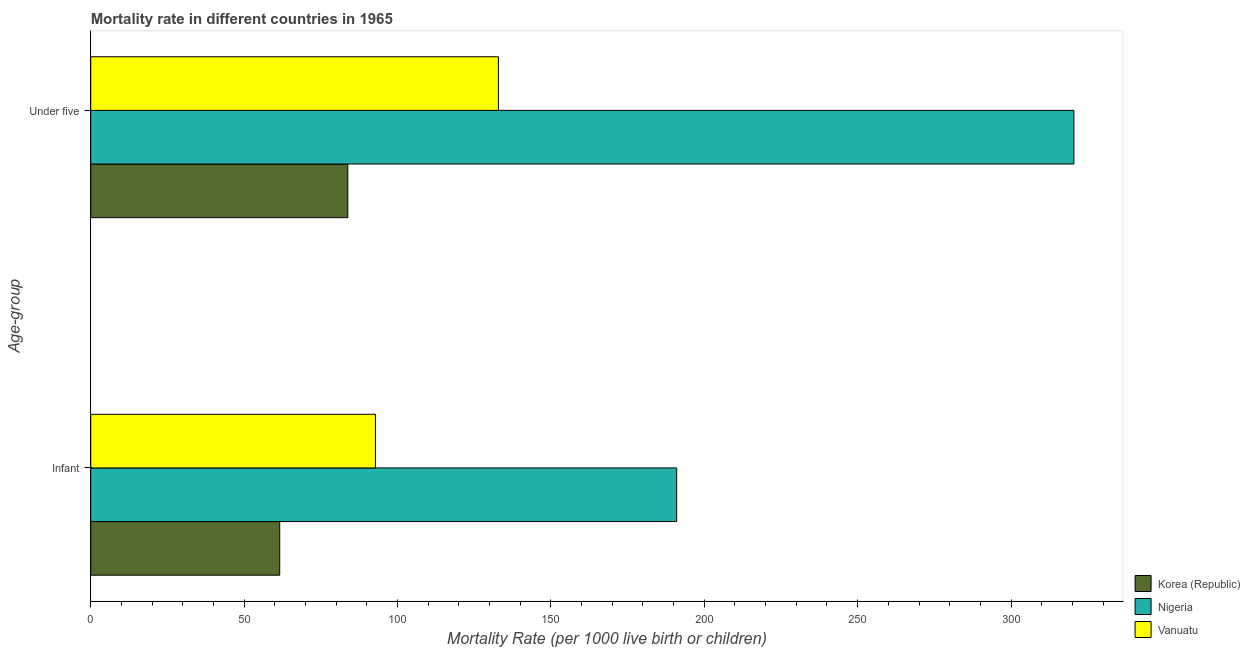How many groups of bars are there?
Your response must be concise. 2. Are the number of bars on each tick of the Y-axis equal?
Your answer should be compact. Yes. How many bars are there on the 1st tick from the top?
Provide a succinct answer. 3. How many bars are there on the 1st tick from the bottom?
Your response must be concise. 3. What is the label of the 1st group of bars from the top?
Your response must be concise. Under five. What is the infant mortality rate in Vanuatu?
Make the answer very short. 92.8. Across all countries, what is the maximum infant mortality rate?
Your answer should be compact. 191. Across all countries, what is the minimum under-5 mortality rate?
Your answer should be compact. 83.8. In which country was the infant mortality rate maximum?
Give a very brief answer. Nigeria. In which country was the infant mortality rate minimum?
Make the answer very short. Korea (Republic). What is the total infant mortality rate in the graph?
Your answer should be very brief. 345.4. What is the difference between the under-5 mortality rate in Nigeria and that in Korea (Republic)?
Provide a succinct answer. 236.7. What is the difference between the under-5 mortality rate in Nigeria and the infant mortality rate in Korea (Republic)?
Your answer should be very brief. 258.9. What is the average under-5 mortality rate per country?
Keep it short and to the point. 179.07. What is the difference between the under-5 mortality rate and infant mortality rate in Korea (Republic)?
Keep it short and to the point. 22.2. In how many countries, is the infant mortality rate greater than 60 ?
Offer a very short reply. 3. What is the ratio of the infant mortality rate in Vanuatu to that in Nigeria?
Give a very brief answer. 0.49. Is the under-5 mortality rate in Korea (Republic) less than that in Vanuatu?
Provide a short and direct response. Yes. In how many countries, is the infant mortality rate greater than the average infant mortality rate taken over all countries?
Keep it short and to the point. 1. What does the 2nd bar from the top in Under five represents?
Give a very brief answer. Nigeria. What does the 3rd bar from the bottom in Infant represents?
Give a very brief answer. Vanuatu. How many bars are there?
Your answer should be compact. 6. Are all the bars in the graph horizontal?
Offer a very short reply. Yes. How many countries are there in the graph?
Your answer should be compact. 3. What is the difference between two consecutive major ticks on the X-axis?
Keep it short and to the point. 50. Does the graph contain any zero values?
Your response must be concise. No. What is the title of the graph?
Provide a short and direct response. Mortality rate in different countries in 1965. What is the label or title of the X-axis?
Keep it short and to the point. Mortality Rate (per 1000 live birth or children). What is the label or title of the Y-axis?
Ensure brevity in your answer.  Age-group. What is the Mortality Rate (per 1000 live birth or children) of Korea (Republic) in Infant?
Give a very brief answer. 61.6. What is the Mortality Rate (per 1000 live birth or children) in Nigeria in Infant?
Ensure brevity in your answer.  191. What is the Mortality Rate (per 1000 live birth or children) of Vanuatu in Infant?
Keep it short and to the point. 92.8. What is the Mortality Rate (per 1000 live birth or children) in Korea (Republic) in Under five?
Give a very brief answer. 83.8. What is the Mortality Rate (per 1000 live birth or children) in Nigeria in Under five?
Make the answer very short. 320.5. What is the Mortality Rate (per 1000 live birth or children) of Vanuatu in Under five?
Your response must be concise. 132.9. Across all Age-group, what is the maximum Mortality Rate (per 1000 live birth or children) of Korea (Republic)?
Your answer should be compact. 83.8. Across all Age-group, what is the maximum Mortality Rate (per 1000 live birth or children) in Nigeria?
Keep it short and to the point. 320.5. Across all Age-group, what is the maximum Mortality Rate (per 1000 live birth or children) of Vanuatu?
Keep it short and to the point. 132.9. Across all Age-group, what is the minimum Mortality Rate (per 1000 live birth or children) of Korea (Republic)?
Provide a short and direct response. 61.6. Across all Age-group, what is the minimum Mortality Rate (per 1000 live birth or children) of Nigeria?
Your answer should be compact. 191. Across all Age-group, what is the minimum Mortality Rate (per 1000 live birth or children) of Vanuatu?
Ensure brevity in your answer.  92.8. What is the total Mortality Rate (per 1000 live birth or children) in Korea (Republic) in the graph?
Your answer should be very brief. 145.4. What is the total Mortality Rate (per 1000 live birth or children) in Nigeria in the graph?
Your answer should be very brief. 511.5. What is the total Mortality Rate (per 1000 live birth or children) of Vanuatu in the graph?
Provide a succinct answer. 225.7. What is the difference between the Mortality Rate (per 1000 live birth or children) of Korea (Republic) in Infant and that in Under five?
Offer a very short reply. -22.2. What is the difference between the Mortality Rate (per 1000 live birth or children) in Nigeria in Infant and that in Under five?
Keep it short and to the point. -129.5. What is the difference between the Mortality Rate (per 1000 live birth or children) in Vanuatu in Infant and that in Under five?
Ensure brevity in your answer.  -40.1. What is the difference between the Mortality Rate (per 1000 live birth or children) of Korea (Republic) in Infant and the Mortality Rate (per 1000 live birth or children) of Nigeria in Under five?
Your response must be concise. -258.9. What is the difference between the Mortality Rate (per 1000 live birth or children) of Korea (Republic) in Infant and the Mortality Rate (per 1000 live birth or children) of Vanuatu in Under five?
Offer a very short reply. -71.3. What is the difference between the Mortality Rate (per 1000 live birth or children) of Nigeria in Infant and the Mortality Rate (per 1000 live birth or children) of Vanuatu in Under five?
Provide a short and direct response. 58.1. What is the average Mortality Rate (per 1000 live birth or children) in Korea (Republic) per Age-group?
Provide a succinct answer. 72.7. What is the average Mortality Rate (per 1000 live birth or children) in Nigeria per Age-group?
Offer a terse response. 255.75. What is the average Mortality Rate (per 1000 live birth or children) in Vanuatu per Age-group?
Keep it short and to the point. 112.85. What is the difference between the Mortality Rate (per 1000 live birth or children) in Korea (Republic) and Mortality Rate (per 1000 live birth or children) in Nigeria in Infant?
Give a very brief answer. -129.4. What is the difference between the Mortality Rate (per 1000 live birth or children) in Korea (Republic) and Mortality Rate (per 1000 live birth or children) in Vanuatu in Infant?
Your answer should be very brief. -31.2. What is the difference between the Mortality Rate (per 1000 live birth or children) in Nigeria and Mortality Rate (per 1000 live birth or children) in Vanuatu in Infant?
Give a very brief answer. 98.2. What is the difference between the Mortality Rate (per 1000 live birth or children) in Korea (Republic) and Mortality Rate (per 1000 live birth or children) in Nigeria in Under five?
Provide a succinct answer. -236.7. What is the difference between the Mortality Rate (per 1000 live birth or children) in Korea (Republic) and Mortality Rate (per 1000 live birth or children) in Vanuatu in Under five?
Give a very brief answer. -49.1. What is the difference between the Mortality Rate (per 1000 live birth or children) of Nigeria and Mortality Rate (per 1000 live birth or children) of Vanuatu in Under five?
Make the answer very short. 187.6. What is the ratio of the Mortality Rate (per 1000 live birth or children) in Korea (Republic) in Infant to that in Under five?
Keep it short and to the point. 0.74. What is the ratio of the Mortality Rate (per 1000 live birth or children) in Nigeria in Infant to that in Under five?
Provide a succinct answer. 0.6. What is the ratio of the Mortality Rate (per 1000 live birth or children) in Vanuatu in Infant to that in Under five?
Make the answer very short. 0.7. What is the difference between the highest and the second highest Mortality Rate (per 1000 live birth or children) of Nigeria?
Your answer should be very brief. 129.5. What is the difference between the highest and the second highest Mortality Rate (per 1000 live birth or children) in Vanuatu?
Provide a succinct answer. 40.1. What is the difference between the highest and the lowest Mortality Rate (per 1000 live birth or children) of Korea (Republic)?
Your response must be concise. 22.2. What is the difference between the highest and the lowest Mortality Rate (per 1000 live birth or children) in Nigeria?
Offer a terse response. 129.5. What is the difference between the highest and the lowest Mortality Rate (per 1000 live birth or children) of Vanuatu?
Offer a terse response. 40.1. 